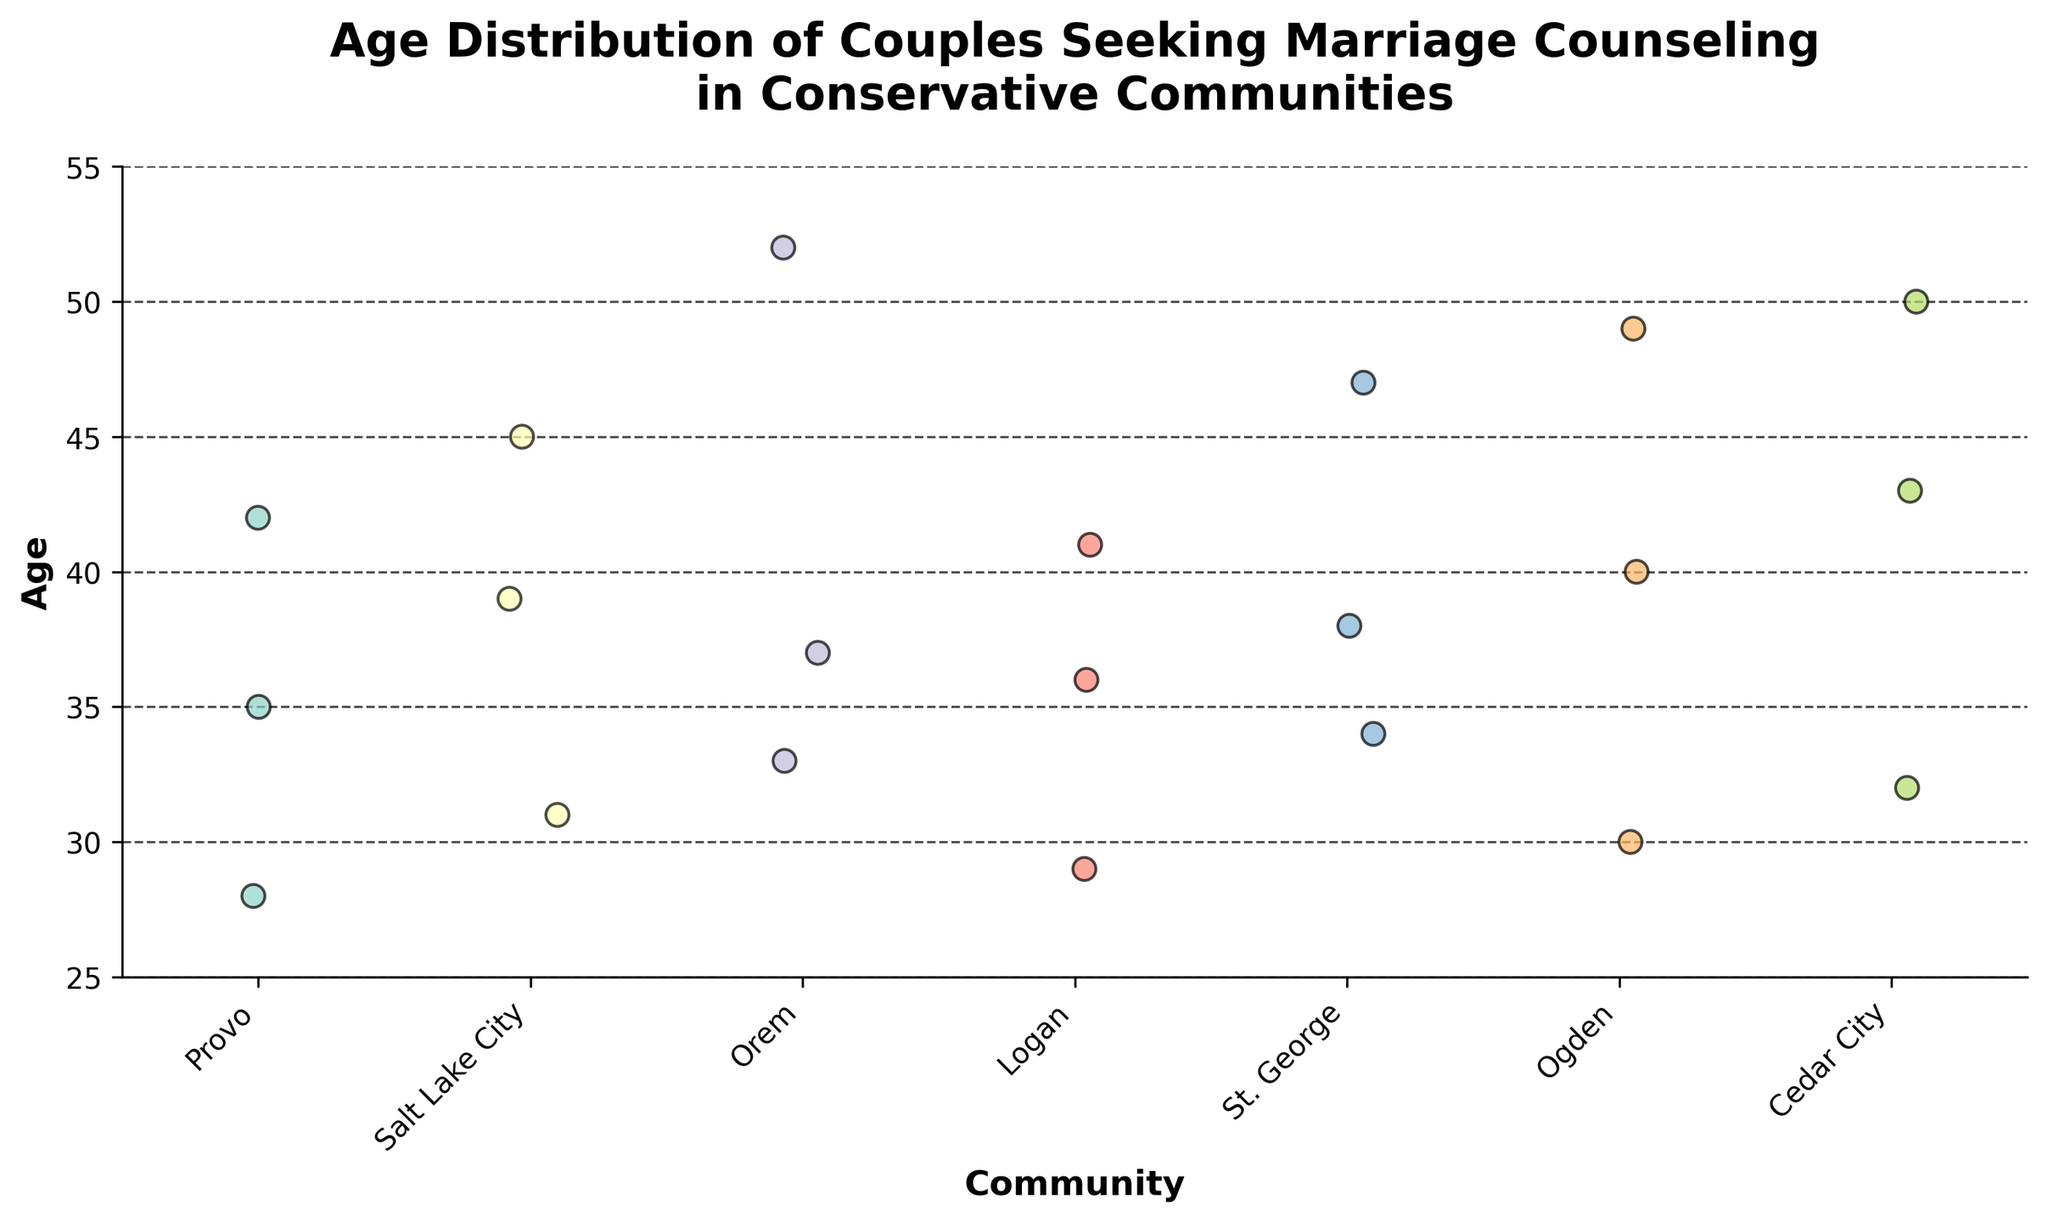What is the title of the plot? The title of the plot is displayed at the top of the figure. It provides a summary of what the plot represents.
Answer: Age Distribution of Couples Seeking Marriage Counseling in Conservative Communities How many communities are represented in the plot? The x-axis lists the different communities involved in the data. By counting these unique communities, we can determine how many are represented.
Answer: 6 Which community has the widest age range of couples seeking marriage counseling? The age values for each community can be observed and the range can be calculated by finding the difference between the highest and lowest ages in each community. The community with the greatest range is the answer.
Answer: Orem What is the median age of couples seeking marriage counseling in Provo? For Provo, the ages are 28, 35, and 42. By arranging these ages in ascending order and identifying the middle value, we find the median age.
Answer: 35 Which community has the oldest individual seeking marriage counseling? By checking the highest age value for each point in the plot for all communities, we find the oldest individual.
Answer: Orem How does the age distribution in Orem compare with that in Logan? Compare the ages plotted for Orem and Logan communities. Consider factors like range, central tendency, and spread to describe the differences.
Answer: Orem has a wider age range and the oldest individual compared to Logan What is the average age of couples seeking counseling in Salt Lake City? The ages in Salt Lake City are 31, 39, and 45. Sum these ages and divide by the number of data points to find the average. (31 + 39 + 45) / 3 = 115 / 3 = 38.33
Answer: 38.33 Are there any communities where all couples are below 40 years old? By looking at the age points for each community and checking if all are less than 40, we determine if any community fits this criterion.
Answer: Yes, Logan Which community has the youngest individual seeking marriage counseling? Identify the lowest age value plotted across all communities to find the youngest individual.
Answer: Provo What is the range of ages for couples in Cedar City? The ages in Cedar City are 32, 43, and 50. The range is calculated by subtracting the minimum age from the maximum age. 50 - 32 = 18
Answer: 18 